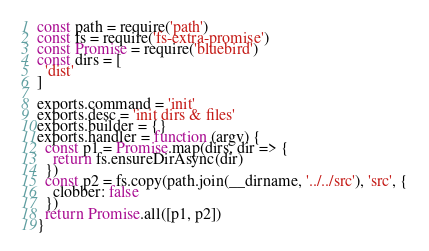Convert code to text. <code><loc_0><loc_0><loc_500><loc_500><_JavaScript_>const path = require('path')
const fs = require('fs-extra-promise')
const Promise = require('bluebird')
const dirs = [
  'dist'
]

exports.command = 'init'
exports.desc = 'init dirs & files'
exports.builder = {}
exports.handler = function (argv) {
  const p1 = Promise.map(dirs, dir => {
    return fs.ensureDirAsync(dir)
  })
  const p2 = fs.copy(path.join(__dirname, '../../src'), 'src', {
    clobber: false
  })
  return Promise.all([p1, p2])
}
</code> 